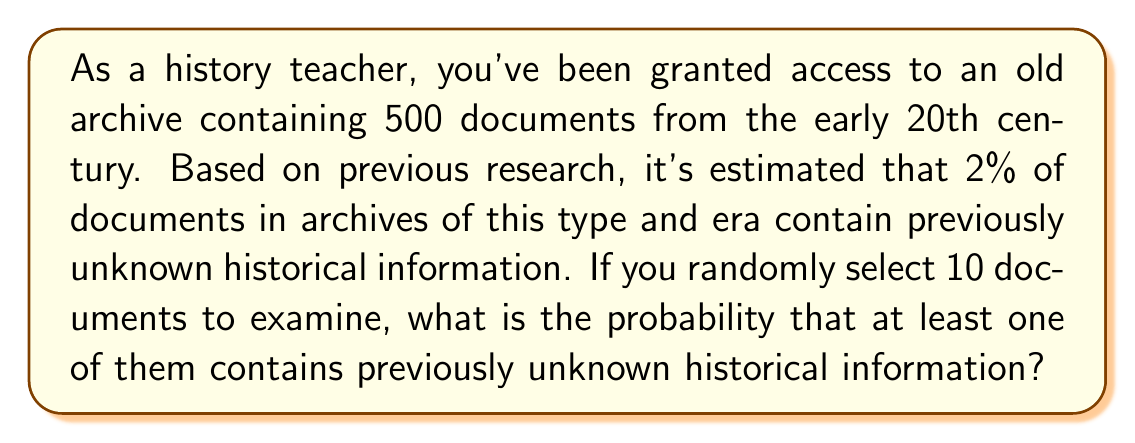Could you help me with this problem? Let's approach this step-by-step:

1) First, we need to calculate the probability of selecting a document with unknown information. This is given as 2% or 0.02.

2) It's easier to calculate the probability of not finding any unknown information and then subtract that from 1 to get our answer.

3) The probability of selecting a document without unknown information is 1 - 0.02 = 0.98.

4) We're selecting 10 documents, so we need to calculate the probability of all 10 not containing unknown information.

5) This can be done by raising 0.98 to the power of 10:

   $$(0.98)^{10}$$

6) We can calculate this:

   $$(0.98)^{10} \approx 0.8179$$

7) This is the probability of not finding any unknown information in 10 documents.

8) To find the probability of finding at least one document with unknown information, we subtract this from 1:

   $$1 - (0.98)^{10} \approx 1 - 0.8179 = 0.1821$$

9) Convert to a percentage:

   $$0.1821 \times 100\% = 18.21\%$$
Answer: The probability of discovering at least one document with previously unknown historical information when randomly selecting 10 documents is approximately 18.21% or 0.1821. 